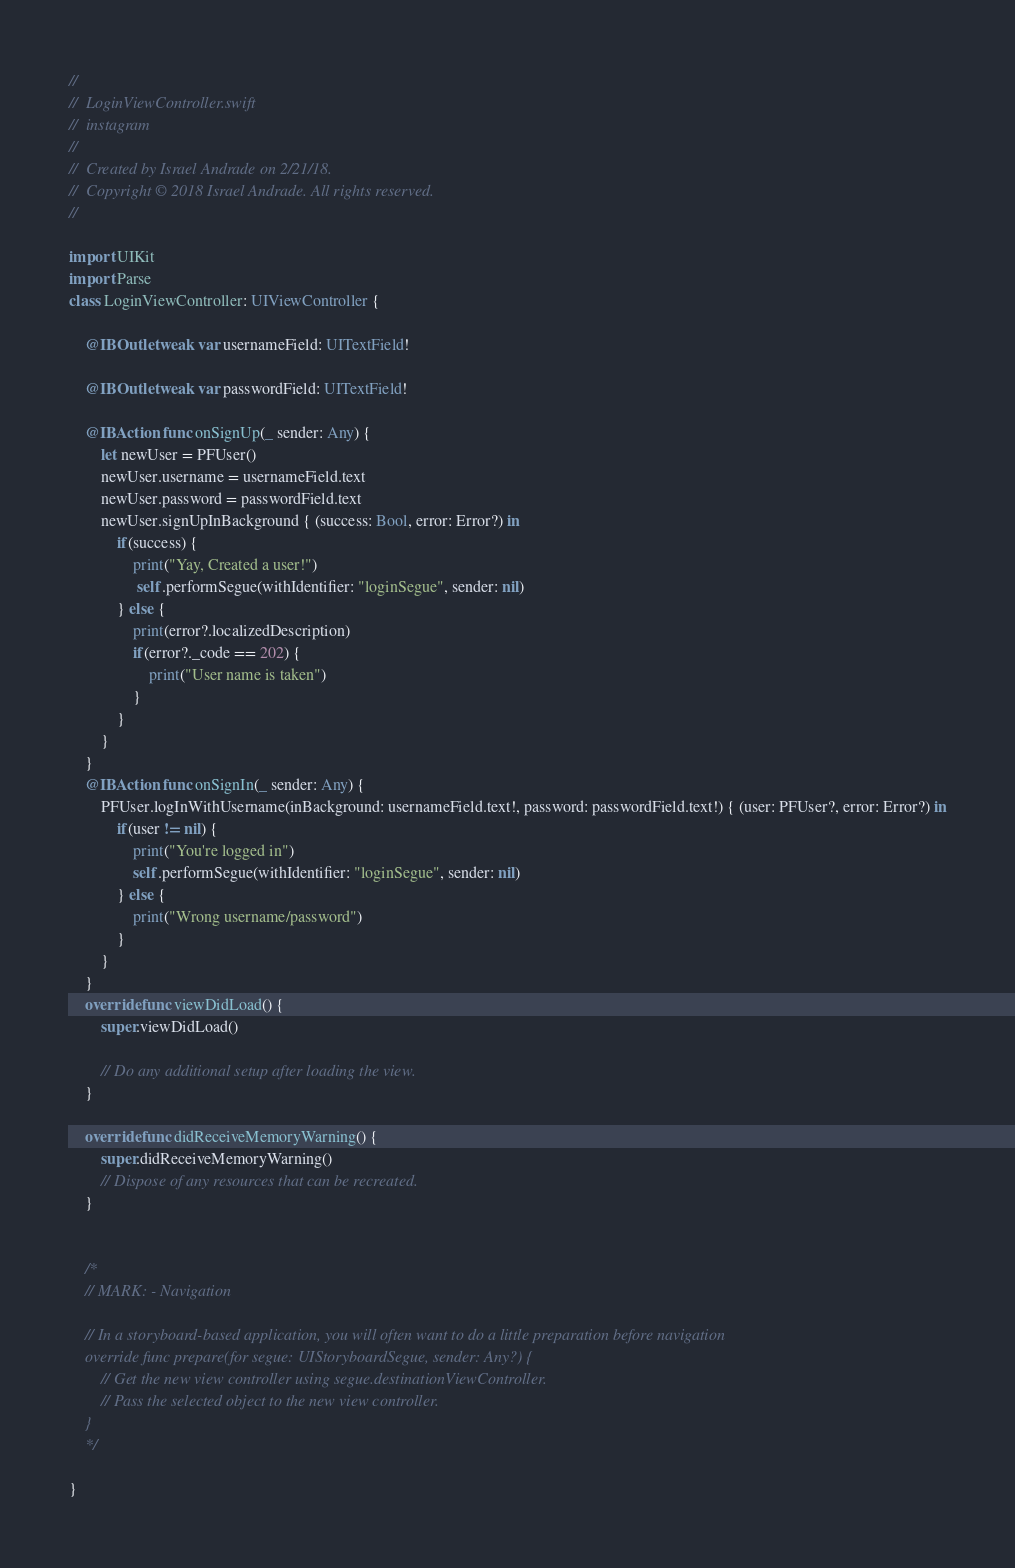<code> <loc_0><loc_0><loc_500><loc_500><_Swift_>//
//  LoginViewController.swift
//  instagram
//
//  Created by Israel Andrade on 2/21/18.
//  Copyright © 2018 Israel Andrade. All rights reserved.
//

import UIKit
import Parse
class LoginViewController: UIViewController {

    @IBOutlet weak var usernameField: UITextField!
    
    @IBOutlet weak var passwordField: UITextField!
    
    @IBAction func onSignUp(_ sender: Any) {
        let newUser = PFUser()
        newUser.username = usernameField.text
        newUser.password = passwordField.text
        newUser.signUpInBackground { (success: Bool, error: Error?) in
            if(success) {
                print("Yay, Created a user!")
                 self.performSegue(withIdentifier: "loginSegue", sender: nil)
            } else {
                print(error?.localizedDescription)
                if(error?._code == 202) {
                    print("User name is taken")
                }
            }
        }
    }
    @IBAction func onSignIn(_ sender: Any) {
        PFUser.logInWithUsername(inBackground: usernameField.text!, password: passwordField.text!) { (user: PFUser?, error: Error?) in
            if(user != nil) {
                print("You're logged in")
                self.performSegue(withIdentifier: "loginSegue", sender: nil)
            } else {
                print("Wrong username/password")
            }
        }
    }
    override func viewDidLoad() {
        super.viewDidLoad()

        // Do any additional setup after loading the view.
    }

    override func didReceiveMemoryWarning() {
        super.didReceiveMemoryWarning()
        // Dispose of any resources that can be recreated.
    }
    

    /*
    // MARK: - Navigation

    // In a storyboard-based application, you will often want to do a little preparation before navigation
    override func prepare(for segue: UIStoryboardSegue, sender: Any?) {
        // Get the new view controller using segue.destinationViewController.
        // Pass the selected object to the new view controller.
    }
    */

}
</code> 